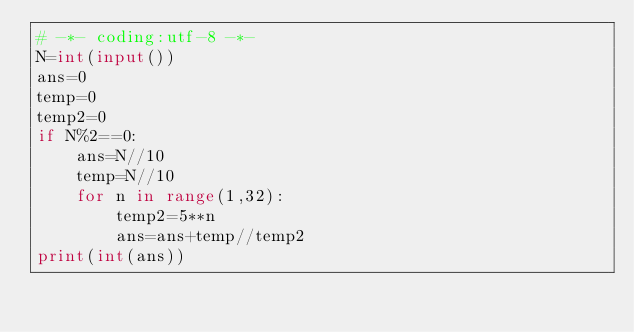<code> <loc_0><loc_0><loc_500><loc_500><_Python_># -*- coding:utf-8 -*-
N=int(input())
ans=0
temp=0
temp2=0
if N%2==0:
    ans=N//10
    temp=N//10
    for n in range(1,32):
        temp2=5**n
        ans=ans+temp//temp2
print(int(ans))</code> 